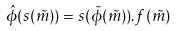<formula> <loc_0><loc_0><loc_500><loc_500>\hat { \phi } ( s ( \tilde { m } ) ) = s ( \tilde { \phi } ( \tilde { m } ) ) . f ( \tilde { m } )</formula> 